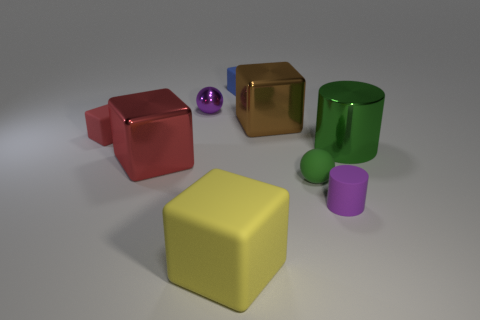There is a small thing that is the same color as the large cylinder; what is its shape?
Your response must be concise. Sphere. What size is the matte thing that is the same color as the tiny metallic object?
Make the answer very short. Small. What number of spheres have the same material as the green cylinder?
Offer a very short reply. 1. What number of matte cubes are the same size as the purple metal thing?
Keep it short and to the point. 2. What material is the small purple object that is left of the big block to the right of the matte cube that is behind the shiny ball?
Make the answer very short. Metal. What number of objects are either small purple metallic objects or small blue matte cubes?
Offer a very short reply. 2. Is there anything else that has the same material as the purple sphere?
Keep it short and to the point. Yes. The small green thing is what shape?
Offer a very short reply. Sphere. The purple thing that is in front of the large object on the right side of the rubber cylinder is what shape?
Ensure brevity in your answer.  Cylinder. Is the material of the tiny cube that is behind the red rubber thing the same as the purple cylinder?
Your response must be concise. Yes. 